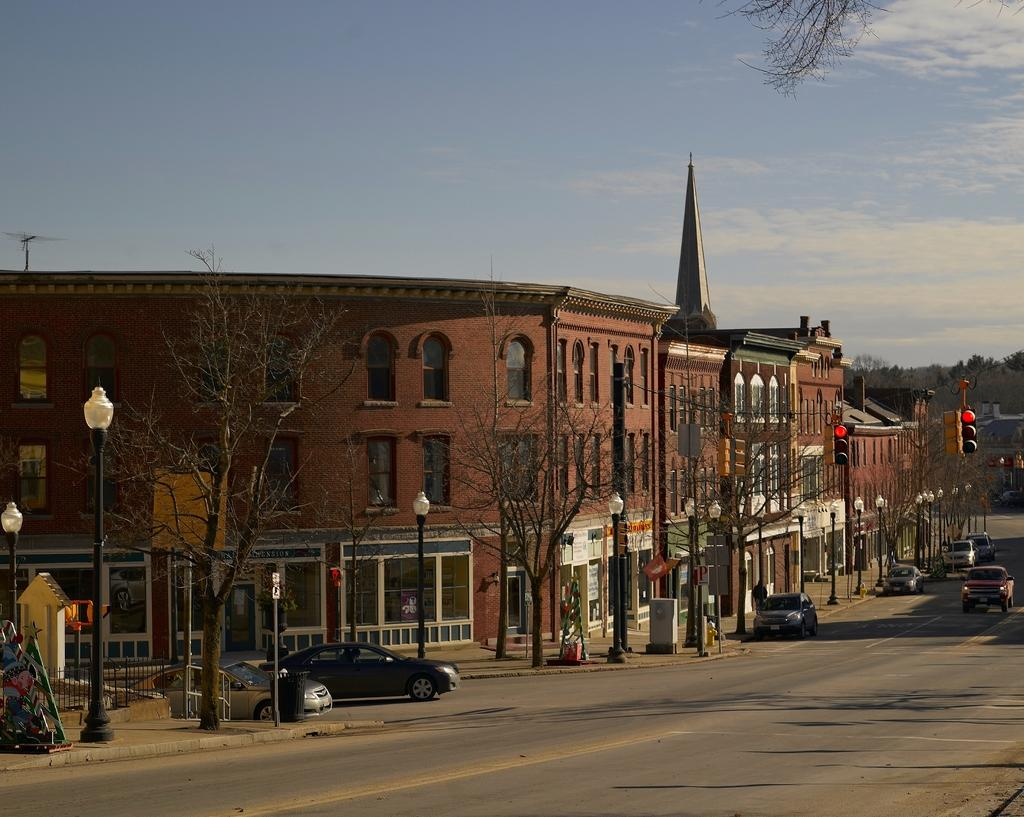What can be seen on the road in the image? There are vehicles on the road in the image. What is visible in the background of the image? There are poles, lights, trees, and a building in the background of the image. What is visible at the top of the image? There are clouds visible at the top of the image. What type of line is being recited in the image? There is no line or verse being recited in the image; it features vehicles on the road and various elements in the background. What is the wealth status of the people in the image? There is no information about the wealth status of the people in the image. 